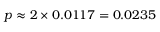Convert formula to latex. <formula><loc_0><loc_0><loc_500><loc_500>p \approx 2 \times 0 . 0 1 1 7 = 0 . 0 2 3 5</formula> 